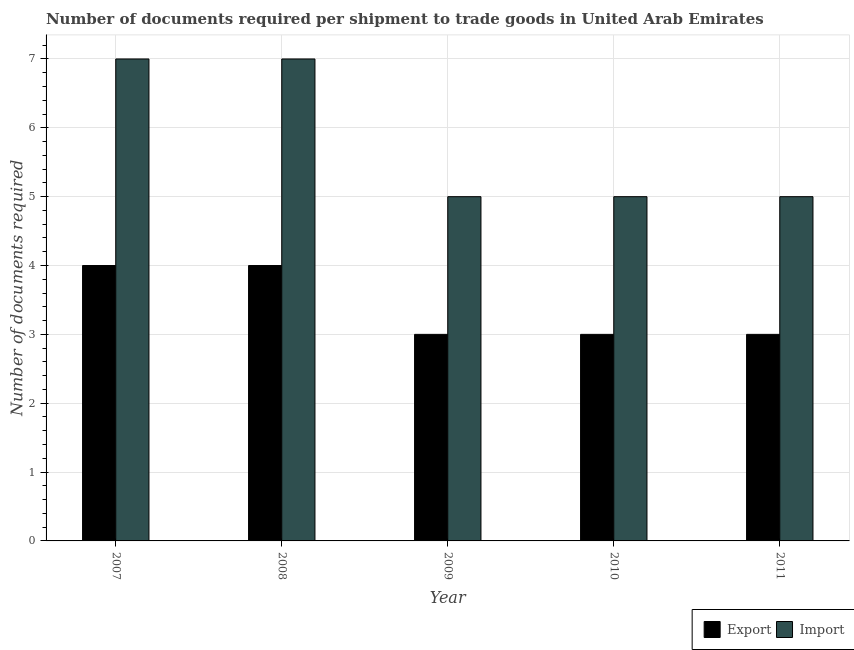How many groups of bars are there?
Your answer should be compact. 5. Are the number of bars per tick equal to the number of legend labels?
Make the answer very short. Yes. Are the number of bars on each tick of the X-axis equal?
Your response must be concise. Yes. What is the label of the 5th group of bars from the left?
Offer a very short reply. 2011. In how many cases, is the number of bars for a given year not equal to the number of legend labels?
Ensure brevity in your answer.  0. What is the number of documents required to import goods in 2010?
Offer a terse response. 5. Across all years, what is the maximum number of documents required to import goods?
Ensure brevity in your answer.  7. Across all years, what is the minimum number of documents required to export goods?
Provide a short and direct response. 3. In which year was the number of documents required to export goods minimum?
Your response must be concise. 2009. What is the total number of documents required to import goods in the graph?
Provide a succinct answer. 29. What is the difference between the number of documents required to export goods in 2010 and that in 2011?
Offer a very short reply. 0. What is the difference between the number of documents required to export goods in 2011 and the number of documents required to import goods in 2007?
Offer a very short reply. -1. What is the average number of documents required to export goods per year?
Keep it short and to the point. 3.4. In the year 2008, what is the difference between the number of documents required to import goods and number of documents required to export goods?
Your answer should be compact. 0. What is the difference between the highest and the lowest number of documents required to import goods?
Your answer should be compact. 2. Is the sum of the number of documents required to import goods in 2008 and 2009 greater than the maximum number of documents required to export goods across all years?
Make the answer very short. Yes. What does the 1st bar from the left in 2008 represents?
Offer a terse response. Export. What does the 1st bar from the right in 2007 represents?
Your response must be concise. Import. Are the values on the major ticks of Y-axis written in scientific E-notation?
Your response must be concise. No. Does the graph contain any zero values?
Your response must be concise. No. Where does the legend appear in the graph?
Ensure brevity in your answer.  Bottom right. How many legend labels are there?
Your response must be concise. 2. What is the title of the graph?
Make the answer very short. Number of documents required per shipment to trade goods in United Arab Emirates. What is the label or title of the X-axis?
Provide a short and direct response. Year. What is the label or title of the Y-axis?
Give a very brief answer. Number of documents required. What is the Number of documents required in Import in 2007?
Offer a terse response. 7. What is the Number of documents required of Import in 2008?
Ensure brevity in your answer.  7. What is the Number of documents required in Export in 2009?
Provide a succinct answer. 3. Across all years, what is the minimum Number of documents required of Export?
Make the answer very short. 3. What is the total Number of documents required of Import in the graph?
Your answer should be compact. 29. What is the difference between the Number of documents required of Export in 2007 and that in 2008?
Your answer should be compact. 0. What is the difference between the Number of documents required of Export in 2007 and that in 2011?
Offer a terse response. 1. What is the difference between the Number of documents required of Export in 2008 and that in 2010?
Your answer should be compact. 1. What is the difference between the Number of documents required in Export in 2008 and that in 2011?
Ensure brevity in your answer.  1. What is the difference between the Number of documents required in Import in 2008 and that in 2011?
Provide a short and direct response. 2. What is the difference between the Number of documents required in Import in 2009 and that in 2010?
Offer a very short reply. 0. What is the difference between the Number of documents required in Import in 2009 and that in 2011?
Provide a succinct answer. 0. What is the difference between the Number of documents required in Export in 2010 and that in 2011?
Provide a succinct answer. 0. What is the difference between the Number of documents required in Import in 2010 and that in 2011?
Your response must be concise. 0. What is the difference between the Number of documents required of Export in 2007 and the Number of documents required of Import in 2008?
Offer a terse response. -3. What is the difference between the Number of documents required in Export in 2007 and the Number of documents required in Import in 2009?
Ensure brevity in your answer.  -1. What is the difference between the Number of documents required of Export in 2007 and the Number of documents required of Import in 2011?
Provide a short and direct response. -1. What is the difference between the Number of documents required in Export in 2008 and the Number of documents required in Import in 2009?
Keep it short and to the point. -1. What is the difference between the Number of documents required in Export in 2008 and the Number of documents required in Import in 2010?
Provide a short and direct response. -1. What is the difference between the Number of documents required of Export in 2008 and the Number of documents required of Import in 2011?
Keep it short and to the point. -1. What is the difference between the Number of documents required in Export in 2010 and the Number of documents required in Import in 2011?
Offer a very short reply. -2. What is the average Number of documents required of Export per year?
Keep it short and to the point. 3.4. In the year 2008, what is the difference between the Number of documents required of Export and Number of documents required of Import?
Your response must be concise. -3. In the year 2010, what is the difference between the Number of documents required of Export and Number of documents required of Import?
Ensure brevity in your answer.  -2. In the year 2011, what is the difference between the Number of documents required in Export and Number of documents required in Import?
Your answer should be very brief. -2. What is the ratio of the Number of documents required of Import in 2007 to that in 2008?
Give a very brief answer. 1. What is the ratio of the Number of documents required in Export in 2007 to that in 2010?
Your response must be concise. 1.33. What is the ratio of the Number of documents required in Import in 2007 to that in 2010?
Offer a very short reply. 1.4. What is the ratio of the Number of documents required of Import in 2007 to that in 2011?
Provide a short and direct response. 1.4. What is the ratio of the Number of documents required in Import in 2008 to that in 2009?
Offer a terse response. 1.4. What is the ratio of the Number of documents required in Export in 2008 to that in 2010?
Offer a very short reply. 1.33. What is the ratio of the Number of documents required of Export in 2008 to that in 2011?
Your answer should be very brief. 1.33. What is the ratio of the Number of documents required of Import in 2008 to that in 2011?
Provide a succinct answer. 1.4. What is the ratio of the Number of documents required of Import in 2009 to that in 2010?
Ensure brevity in your answer.  1. What is the ratio of the Number of documents required in Import in 2009 to that in 2011?
Offer a terse response. 1. What is the difference between the highest and the second highest Number of documents required in Export?
Your answer should be compact. 0. What is the difference between the highest and the second highest Number of documents required of Import?
Make the answer very short. 0. What is the difference between the highest and the lowest Number of documents required in Export?
Make the answer very short. 1. 